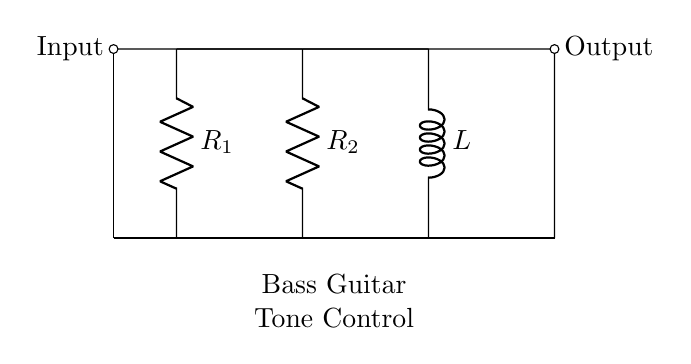What are the components in this circuit? The circuit consists of two resistors labeled R1 and R2, and one inductor labeled L, with their respective connections highlighted.
Answer: R1, R2, L What is the function of the inductor in this circuit? The inductor is used for tone control in the bass guitar, filtering certain frequencies and affecting the overall sound output.
Answer: Tone control How many resistors are present in the circuit? The circuit diagram indicates two resistors, R1 and R2, both of which are connected in series with the inductor L.
Answer: Two What is the type of connection between the components? The components are connected in series, allowing the current to flow through R1, then R2, and finally L before reaching the output.
Answer: Series What would happen if R1 were removed from the circuit? Removing R1 would change the total resistance of the circuit, potentially allowing more current to flow and affecting tone control as the frequency response might shift.
Answer: Increased current How does the circuit affect bass frequency response? The combination of resistors and inductors creates a filter that boosts or cuts certain bass frequencies, allowing for finer control of the tonal characteristics of the guitar output.
Answer: Frequency filtering 